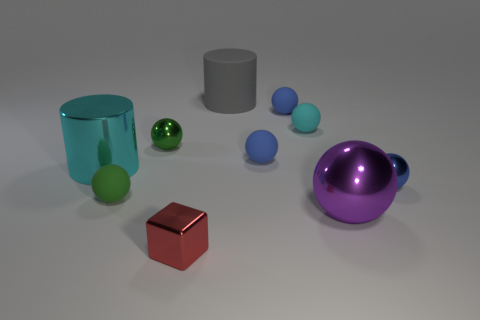What is the color of the cube?
Make the answer very short. Red. What number of large objects are either brown shiny blocks or balls?
Your answer should be compact. 1. What is the material of the tiny thing that is the same color as the big metal cylinder?
Your answer should be compact. Rubber. Is the material of the ball that is behind the cyan ball the same as the large thing that is in front of the cyan metal object?
Make the answer very short. No. Are any tiny red balls visible?
Ensure brevity in your answer.  No. Is the number of small metallic objects that are left of the large purple thing greater than the number of small spheres behind the rubber cylinder?
Your response must be concise. Yes. What is the material of the big purple object that is the same shape as the blue metallic thing?
Ensure brevity in your answer.  Metal. Does the metal sphere that is to the left of the large rubber cylinder have the same color as the matte thing to the left of the red thing?
Keep it short and to the point. Yes. What is the shape of the big cyan metallic object?
Provide a succinct answer. Cylinder. Are there more blue balls that are to the left of the large gray cylinder than green metal spheres?
Make the answer very short. No. 